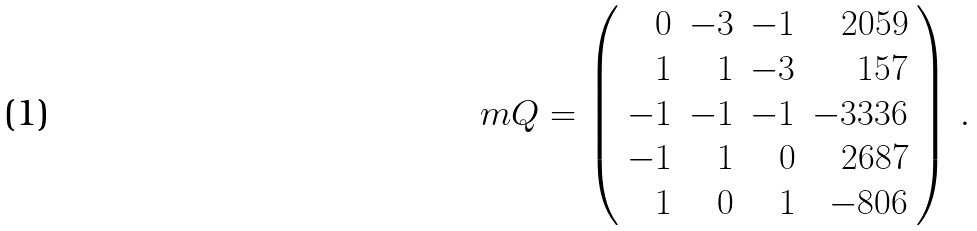<formula> <loc_0><loc_0><loc_500><loc_500>\ m Q = \left ( \begin{array} { r r r r } 0 & - 3 & - 1 & 2 0 5 9 \\ 1 & 1 & - 3 & 1 5 7 \\ - 1 & - 1 & - 1 & - 3 3 3 6 \\ - 1 & 1 & 0 & 2 6 8 7 \\ 1 & 0 & 1 & - 8 0 6 \end{array} \right ) \, .</formula> 